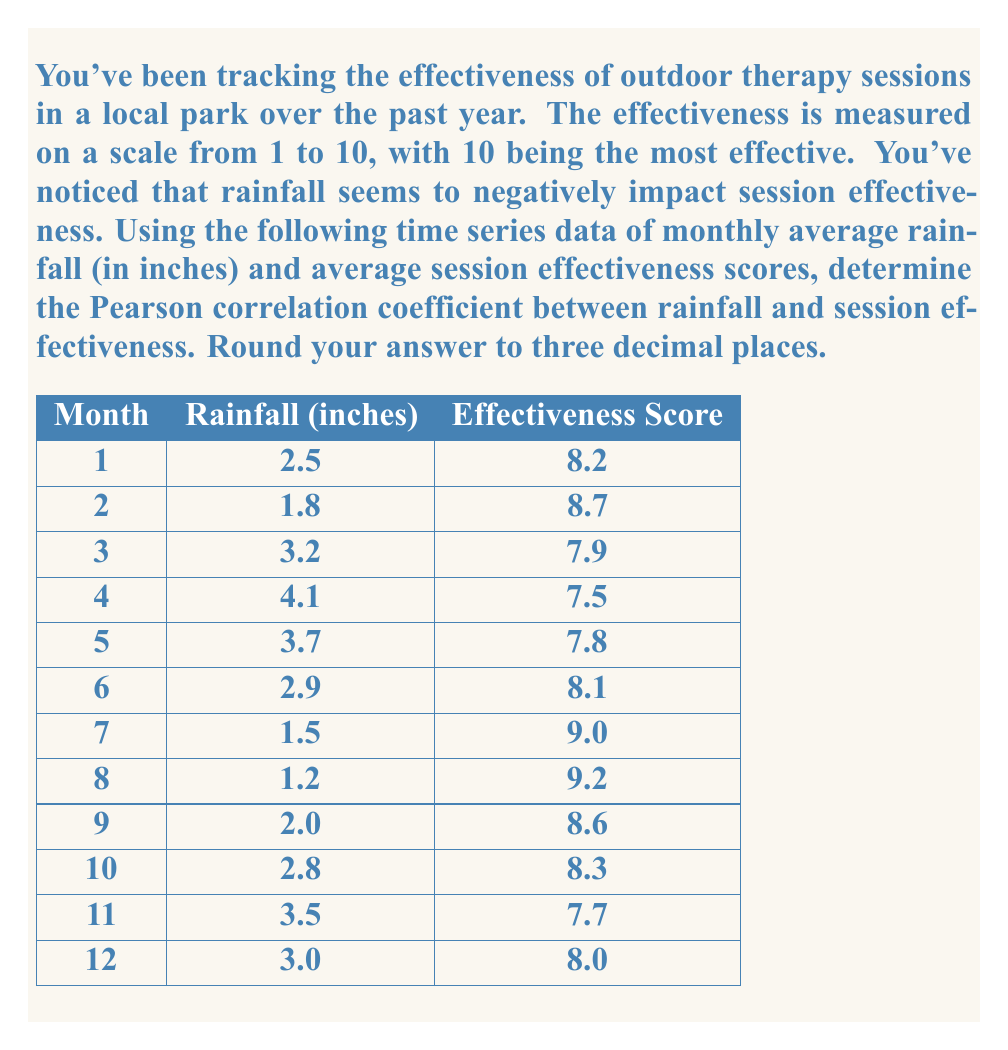Help me with this question. To calculate the Pearson correlation coefficient between rainfall and session effectiveness, we'll use the following formula:

$$ r = \frac{\sum_{i=1}^{n} (x_i - \bar{x})(y_i - \bar{y})}{\sqrt{\sum_{i=1}^{n} (x_i - \bar{x})^2 \sum_{i=1}^{n} (y_i - \bar{y})^2}} $$

Where:
$x_i$ represents rainfall values
$y_i$ represents effectiveness scores
$\bar{x}$ is the mean of rainfall values
$\bar{y}$ is the mean of effectiveness scores
$n$ is the number of data points (12 in this case)

Step 1: Calculate means
$\bar{x} = \frac{2.5 + 1.8 + 3.2 + 4.1 + 3.7 + 2.9 + 1.5 + 1.2 + 2.0 + 2.8 + 3.5 + 3.0}{12} = 2.683$
$\bar{y} = \frac{8.2 + 8.7 + 7.9 + 7.5 + 7.8 + 8.1 + 9.0 + 9.2 + 8.6 + 8.3 + 7.7 + 8.0}{12} = 8.250$

Step 2: Calculate $(x_i - \bar{x})$, $(y_i - \bar{y})$, $(x_i - \bar{x})^2$, $(y_i - \bar{y})^2$, and $(x_i - \bar{x})(y_i - \bar{y})$ for each data point.

Step 3: Sum up the values calculated in Step 2:
$\sum (x_i - \bar{x})(y_i - \bar{y}) = -2.859$
$\sum (x_i - \bar{x})^2 = 9.649$
$\sum (y_i - \bar{y})^2 = 3.250$

Step 4: Apply the formula:

$$ r = \frac{-2.859}{\sqrt{9.649 \times 3.250}} = -0.932 $$

Step 5: Round to three decimal places: -0.932
Answer: -0.932 